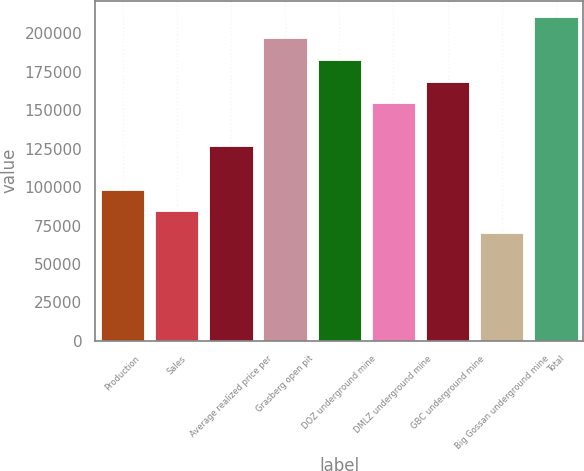Convert chart. <chart><loc_0><loc_0><loc_500><loc_500><bar_chart><fcel>Production<fcel>Sales<fcel>Average realized price per<fcel>Grasberg open pit<fcel>DOZ underground mine<fcel>DMLZ underground mine<fcel>GBC underground mine<fcel>Big Gossan underground mine<fcel>Total<nl><fcel>98280.3<fcel>84240.4<fcel>126360<fcel>196560<fcel>182520<fcel>154440<fcel>168480<fcel>70200.5<fcel>210600<nl></chart> 